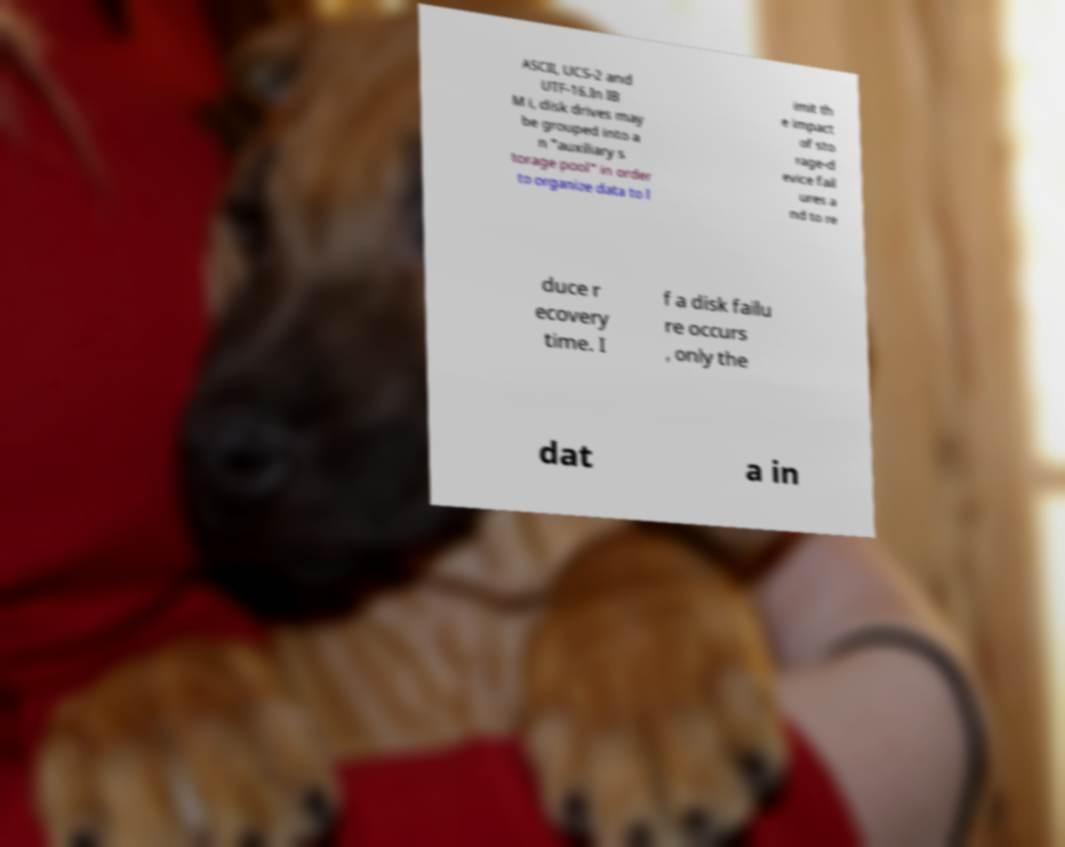Please identify and transcribe the text found in this image. ASCII, UCS-2 and UTF-16.In IB M i, disk drives may be grouped into a n "auxiliary s torage pool" in order to organize data to l imit th e impact of sto rage-d evice fail ures a nd to re duce r ecovery time. I f a disk failu re occurs , only the dat a in 